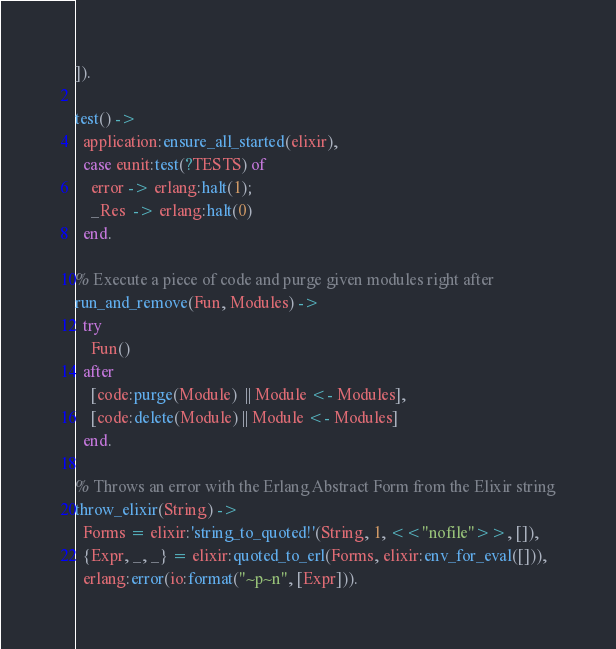<code> <loc_0><loc_0><loc_500><loc_500><_Erlang_>]).

test() ->
  application:ensure_all_started(elixir),
  case eunit:test(?TESTS) of
    error -> erlang:halt(1);
    _Res  -> erlang:halt(0)
  end.

% Execute a piece of code and purge given modules right after
run_and_remove(Fun, Modules) ->
  try
    Fun()
  after
    [code:purge(Module)  || Module <- Modules],
    [code:delete(Module) || Module <- Modules]
  end.

% Throws an error with the Erlang Abstract Form from the Elixir string
throw_elixir(String) ->
  Forms = elixir:'string_to_quoted!'(String, 1, <<"nofile">>, []),
  {Expr, _, _} = elixir:quoted_to_erl(Forms, elixir:env_for_eval([])),
  erlang:error(io:format("~p~n", [Expr])).
</code> 